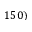<formula> <loc_0><loc_0><loc_500><loc_500>1 5 0 )</formula> 